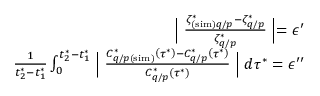Convert formula to latex. <formula><loc_0><loc_0><loc_500><loc_500>\begin{array} { r } { \left | \frac { \zeta _ { ( s i m ) q / p } ^ { * } - \zeta _ { q / p } ^ { * } } { \zeta _ { q / p } ^ { * } } \right | = \epsilon ^ { \prime } } \\ { \frac { 1 } { t _ { 2 } ^ { * } - t _ { 1 } ^ { * } } \int _ { 0 } ^ { t _ { 2 } ^ { * } - t _ { 1 } ^ { * } } \left | \frac { C _ { q / p ( s i m ) } ^ { * } \left ( \tau ^ { * } \right ) - C _ { q / p } ^ { * } \left ( \tau ^ { * } \right ) } { C _ { q / p } ^ { * } \left ( \tau ^ { * } \right ) } \right | d \tau ^ { * } = \epsilon ^ { \prime \prime } } \end{array}</formula> 